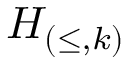Convert formula to latex. <formula><loc_0><loc_0><loc_500><loc_500>H _ { ( \leq , k ) }</formula> 